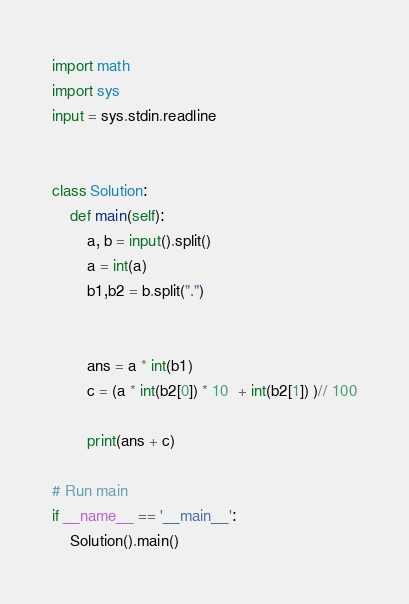Convert code to text. <code><loc_0><loc_0><loc_500><loc_500><_Python_>import math
import sys
input = sys.stdin.readline


class Solution:
    def main(self):
        a, b = input().split()
        a = int(a)
        b1,b2 = b.split(".")


        ans = a * int(b1)
        c = (a * int(b2[0]) * 10  + int(b2[1]) )// 100

        print(ans + c)

# Run main
if __name__ == '__main__':
    Solution().main()</code> 